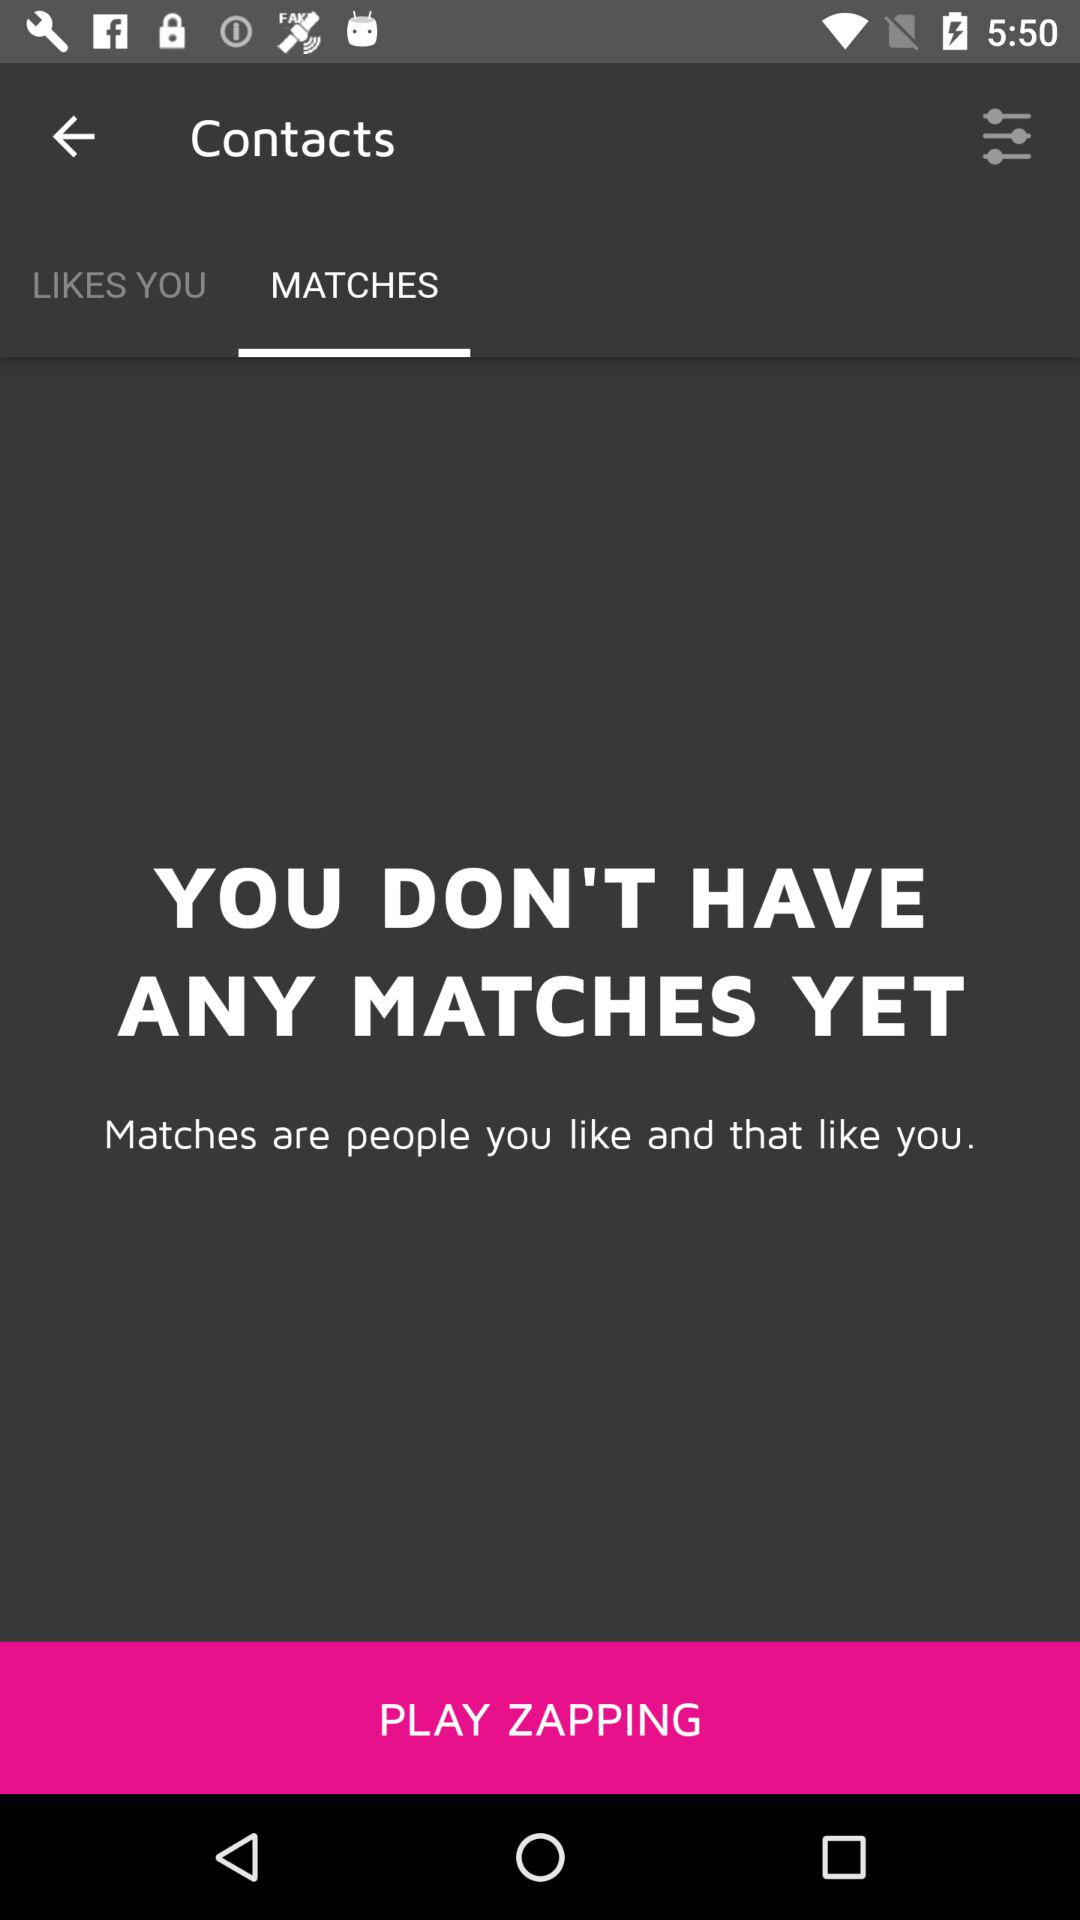How many matches do I have?
Answer the question using a single word or phrase. 0 